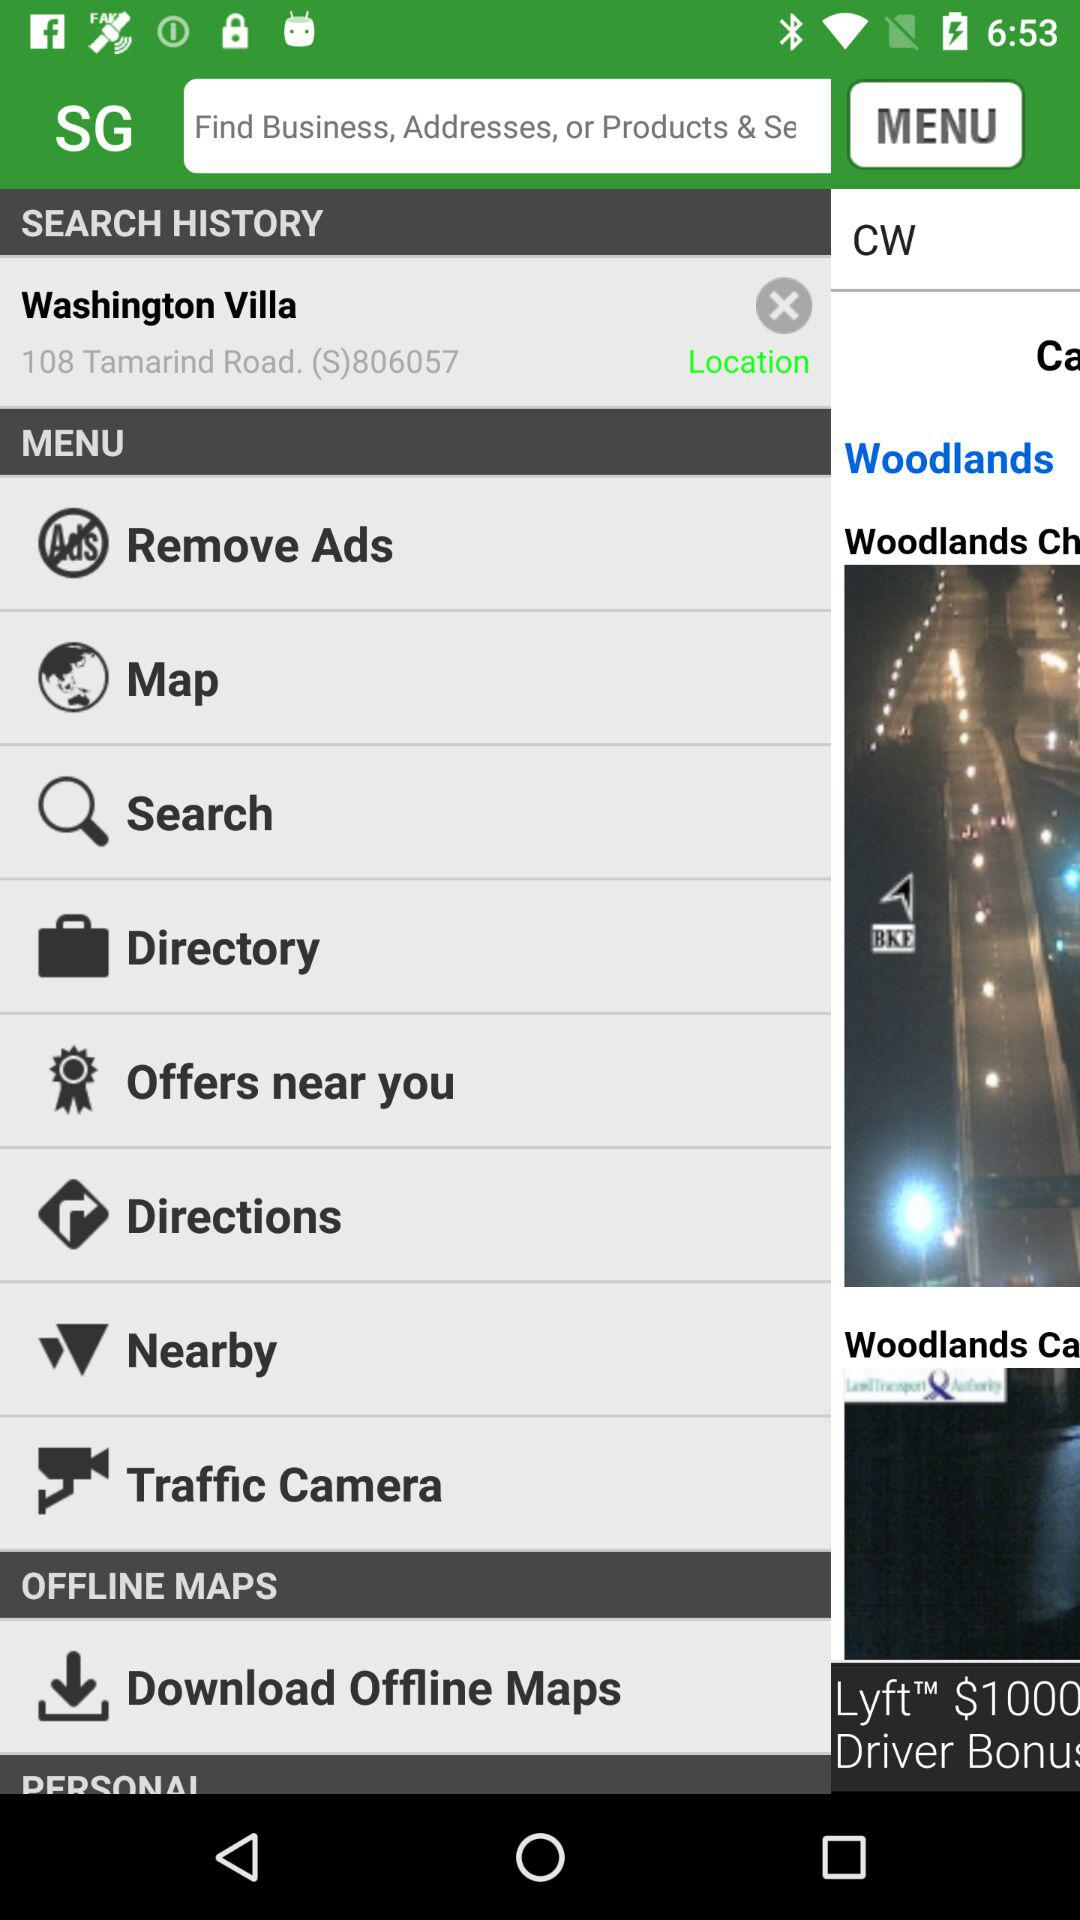What's the address of the villa in Washington? The address of the villa in Washington is 108 Tamarind Road. (S)806057. 